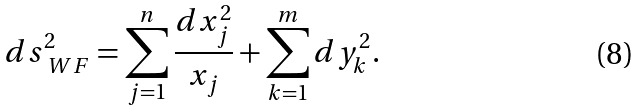<formula> <loc_0><loc_0><loc_500><loc_500>d s ^ { 2 } _ { \ W F } = \sum _ { j = 1 } ^ { n } \frac { d x _ { j } ^ { 2 } } { x _ { j } } + \sum _ { k = 1 } ^ { m } d y _ { k } ^ { 2 } .</formula> 